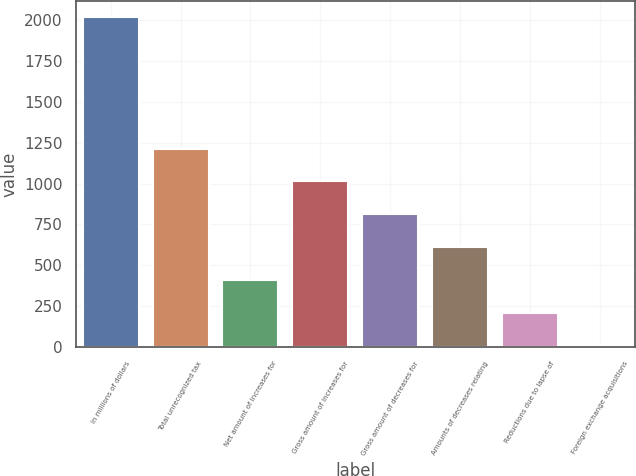Convert chart. <chart><loc_0><loc_0><loc_500><loc_500><bar_chart><fcel>In millions of dollars<fcel>Total unrecognized tax<fcel>Net amount of increases for<fcel>Gross amount of increases for<fcel>Gross amount of decreases for<fcel>Amounts of decreases relating<fcel>Reductions due to lapse of<fcel>Foreign exchange acquisitions<nl><fcel>2017<fcel>1214.2<fcel>411.4<fcel>1013.5<fcel>812.8<fcel>612.1<fcel>210.7<fcel>10<nl></chart> 